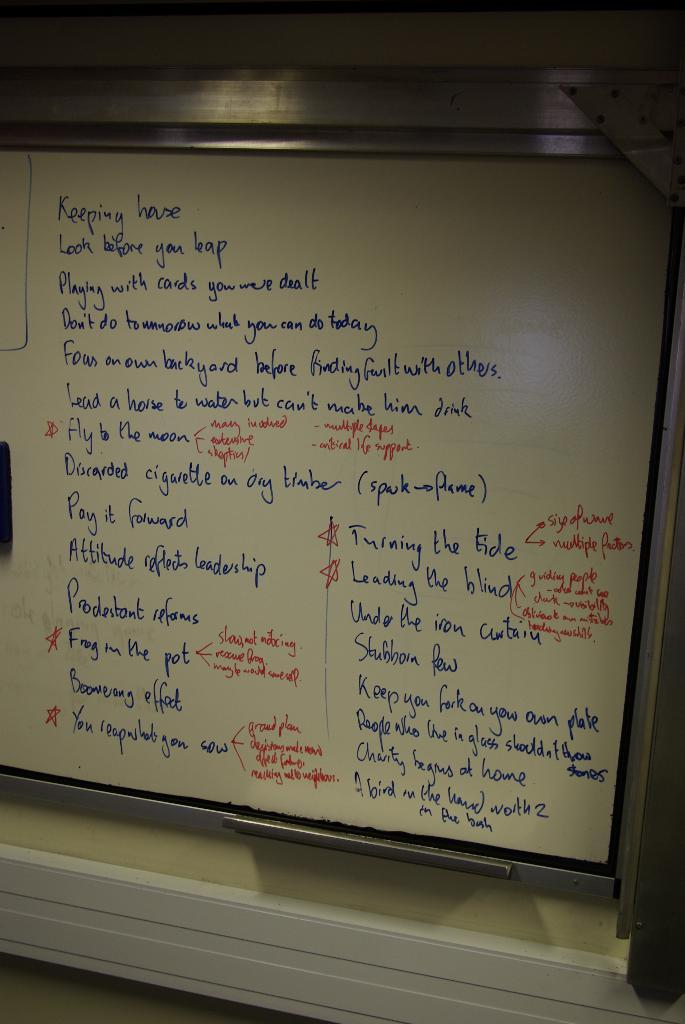<image>
Share a concise interpretation of the image provided. A list of sayings is on a whiteboard, including 'look before your leap' and 'you reap what you sow'. 